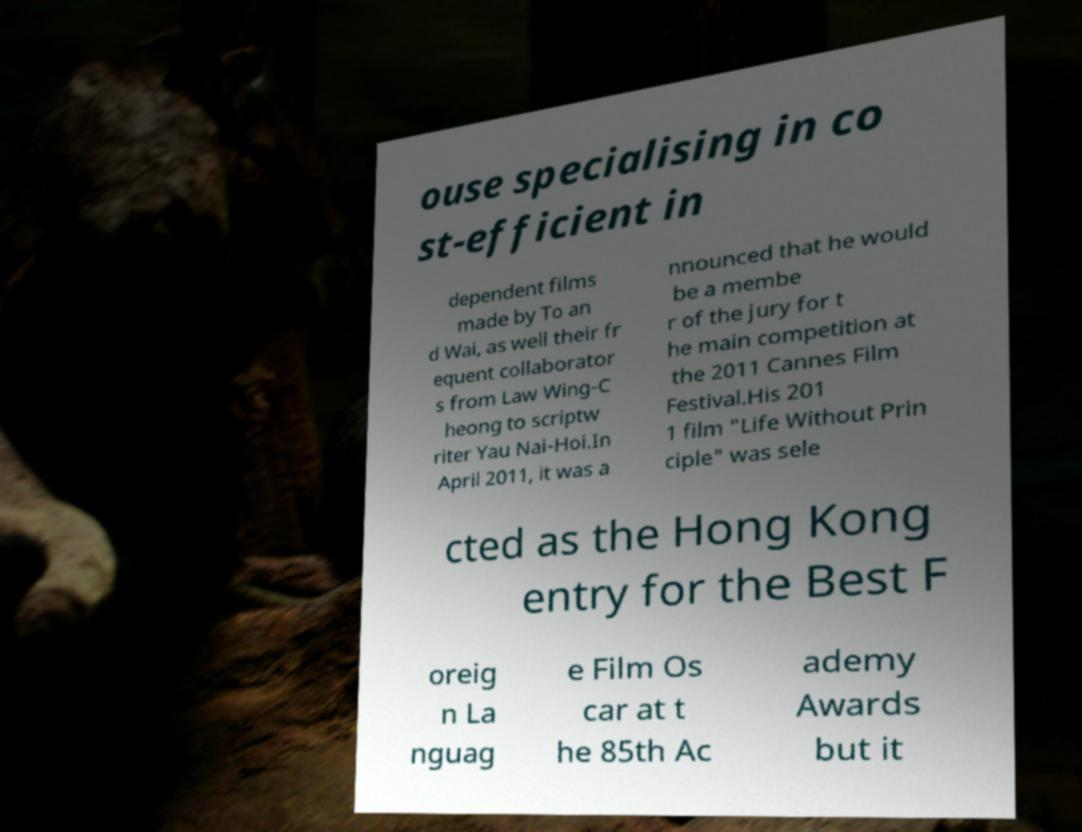There's text embedded in this image that I need extracted. Can you transcribe it verbatim? ouse specialising in co st-efficient in dependent films made by To an d Wai, as well their fr equent collaborator s from Law Wing-C heong to scriptw riter Yau Nai-Hoi.In April 2011, it was a nnounced that he would be a membe r of the jury for t he main competition at the 2011 Cannes Film Festival.His 201 1 film "Life Without Prin ciple" was sele cted as the Hong Kong entry for the Best F oreig n La nguag e Film Os car at t he 85th Ac ademy Awards but it 